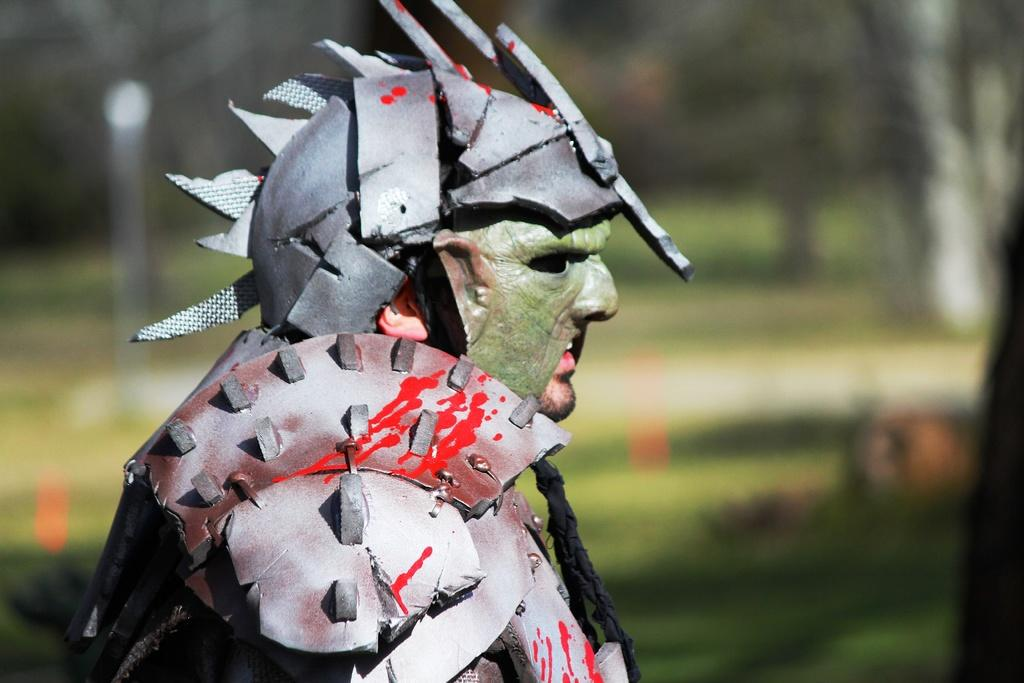Where was the image taken? The image was clicked outside. What is the main subject of the image? There is a person in the center of the image. What is the person wearing in the image? The person is wearing metal objects. Can you describe the background of the image? The background of the image is blurry. What type of cherry is the person holding in the image? There is no cherry present in the image. Is the person wearing a hat in the image? The provided facts do not mention a hat, so we cannot determine if the person is wearing one. What type of plough is visible in the image? There is no plough present in the image. 